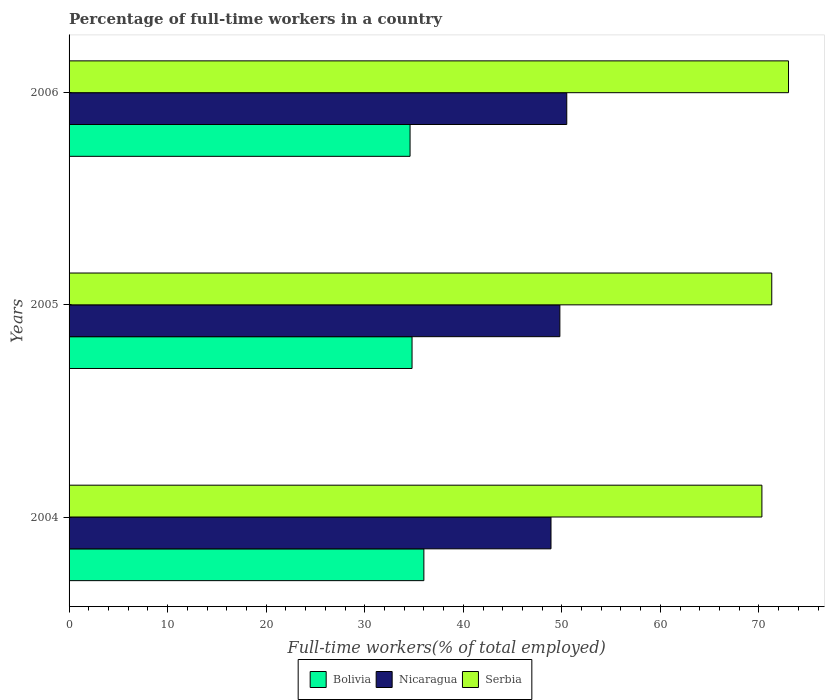How many different coloured bars are there?
Give a very brief answer. 3. Are the number of bars on each tick of the Y-axis equal?
Give a very brief answer. Yes. How many bars are there on the 3rd tick from the bottom?
Your answer should be compact. 3. What is the label of the 3rd group of bars from the top?
Make the answer very short. 2004. In how many cases, is the number of bars for a given year not equal to the number of legend labels?
Your answer should be compact. 0. What is the percentage of full-time workers in Serbia in 2005?
Your answer should be compact. 71.3. Across all years, what is the maximum percentage of full-time workers in Bolivia?
Provide a succinct answer. 36. Across all years, what is the minimum percentage of full-time workers in Nicaragua?
Keep it short and to the point. 48.9. What is the total percentage of full-time workers in Nicaragua in the graph?
Give a very brief answer. 149.2. What is the difference between the percentage of full-time workers in Nicaragua in 2004 and that in 2006?
Provide a succinct answer. -1.6. What is the difference between the percentage of full-time workers in Bolivia in 2004 and the percentage of full-time workers in Serbia in 2006?
Offer a terse response. -37. What is the average percentage of full-time workers in Bolivia per year?
Your response must be concise. 35.13. In the year 2006, what is the difference between the percentage of full-time workers in Serbia and percentage of full-time workers in Bolivia?
Give a very brief answer. 38.4. In how many years, is the percentage of full-time workers in Bolivia greater than 58 %?
Provide a succinct answer. 0. What is the ratio of the percentage of full-time workers in Bolivia in 2004 to that in 2005?
Provide a short and direct response. 1.03. What is the difference between the highest and the second highest percentage of full-time workers in Serbia?
Provide a short and direct response. 1.7. What is the difference between the highest and the lowest percentage of full-time workers in Bolivia?
Your answer should be compact. 1.4. Is the sum of the percentage of full-time workers in Serbia in 2004 and 2006 greater than the maximum percentage of full-time workers in Bolivia across all years?
Your answer should be compact. Yes. What does the 1st bar from the top in 2004 represents?
Provide a short and direct response. Serbia. What does the 2nd bar from the bottom in 2006 represents?
Your response must be concise. Nicaragua. How many bars are there?
Your answer should be compact. 9. Are all the bars in the graph horizontal?
Provide a succinct answer. Yes. What is the title of the graph?
Your answer should be compact. Percentage of full-time workers in a country. What is the label or title of the X-axis?
Your answer should be very brief. Full-time workers(% of total employed). What is the Full-time workers(% of total employed) of Nicaragua in 2004?
Your answer should be compact. 48.9. What is the Full-time workers(% of total employed) in Serbia in 2004?
Make the answer very short. 70.3. What is the Full-time workers(% of total employed) of Bolivia in 2005?
Ensure brevity in your answer.  34.8. What is the Full-time workers(% of total employed) of Nicaragua in 2005?
Your answer should be very brief. 49.8. What is the Full-time workers(% of total employed) in Serbia in 2005?
Provide a short and direct response. 71.3. What is the Full-time workers(% of total employed) in Bolivia in 2006?
Make the answer very short. 34.6. What is the Full-time workers(% of total employed) in Nicaragua in 2006?
Ensure brevity in your answer.  50.5. Across all years, what is the maximum Full-time workers(% of total employed) in Bolivia?
Your answer should be very brief. 36. Across all years, what is the maximum Full-time workers(% of total employed) of Nicaragua?
Provide a succinct answer. 50.5. Across all years, what is the minimum Full-time workers(% of total employed) of Bolivia?
Keep it short and to the point. 34.6. Across all years, what is the minimum Full-time workers(% of total employed) of Nicaragua?
Provide a succinct answer. 48.9. Across all years, what is the minimum Full-time workers(% of total employed) of Serbia?
Make the answer very short. 70.3. What is the total Full-time workers(% of total employed) of Bolivia in the graph?
Provide a succinct answer. 105.4. What is the total Full-time workers(% of total employed) of Nicaragua in the graph?
Your answer should be compact. 149.2. What is the total Full-time workers(% of total employed) of Serbia in the graph?
Make the answer very short. 214.6. What is the difference between the Full-time workers(% of total employed) of Bolivia in 2004 and that in 2005?
Make the answer very short. 1.2. What is the difference between the Full-time workers(% of total employed) of Nicaragua in 2004 and that in 2005?
Make the answer very short. -0.9. What is the difference between the Full-time workers(% of total employed) of Bolivia in 2004 and that in 2006?
Provide a succinct answer. 1.4. What is the difference between the Full-time workers(% of total employed) in Nicaragua in 2005 and that in 2006?
Provide a short and direct response. -0.7. What is the difference between the Full-time workers(% of total employed) in Bolivia in 2004 and the Full-time workers(% of total employed) in Serbia in 2005?
Provide a succinct answer. -35.3. What is the difference between the Full-time workers(% of total employed) of Nicaragua in 2004 and the Full-time workers(% of total employed) of Serbia in 2005?
Provide a succinct answer. -22.4. What is the difference between the Full-time workers(% of total employed) of Bolivia in 2004 and the Full-time workers(% of total employed) of Nicaragua in 2006?
Offer a terse response. -14.5. What is the difference between the Full-time workers(% of total employed) of Bolivia in 2004 and the Full-time workers(% of total employed) of Serbia in 2006?
Your response must be concise. -37. What is the difference between the Full-time workers(% of total employed) of Nicaragua in 2004 and the Full-time workers(% of total employed) of Serbia in 2006?
Your answer should be very brief. -24.1. What is the difference between the Full-time workers(% of total employed) in Bolivia in 2005 and the Full-time workers(% of total employed) in Nicaragua in 2006?
Make the answer very short. -15.7. What is the difference between the Full-time workers(% of total employed) of Bolivia in 2005 and the Full-time workers(% of total employed) of Serbia in 2006?
Your response must be concise. -38.2. What is the difference between the Full-time workers(% of total employed) of Nicaragua in 2005 and the Full-time workers(% of total employed) of Serbia in 2006?
Offer a very short reply. -23.2. What is the average Full-time workers(% of total employed) in Bolivia per year?
Make the answer very short. 35.13. What is the average Full-time workers(% of total employed) of Nicaragua per year?
Your answer should be compact. 49.73. What is the average Full-time workers(% of total employed) in Serbia per year?
Give a very brief answer. 71.53. In the year 2004, what is the difference between the Full-time workers(% of total employed) of Bolivia and Full-time workers(% of total employed) of Nicaragua?
Make the answer very short. -12.9. In the year 2004, what is the difference between the Full-time workers(% of total employed) of Bolivia and Full-time workers(% of total employed) of Serbia?
Your response must be concise. -34.3. In the year 2004, what is the difference between the Full-time workers(% of total employed) in Nicaragua and Full-time workers(% of total employed) in Serbia?
Your answer should be compact. -21.4. In the year 2005, what is the difference between the Full-time workers(% of total employed) of Bolivia and Full-time workers(% of total employed) of Nicaragua?
Keep it short and to the point. -15. In the year 2005, what is the difference between the Full-time workers(% of total employed) of Bolivia and Full-time workers(% of total employed) of Serbia?
Make the answer very short. -36.5. In the year 2005, what is the difference between the Full-time workers(% of total employed) in Nicaragua and Full-time workers(% of total employed) in Serbia?
Keep it short and to the point. -21.5. In the year 2006, what is the difference between the Full-time workers(% of total employed) in Bolivia and Full-time workers(% of total employed) in Nicaragua?
Your answer should be very brief. -15.9. In the year 2006, what is the difference between the Full-time workers(% of total employed) of Bolivia and Full-time workers(% of total employed) of Serbia?
Your answer should be compact. -38.4. In the year 2006, what is the difference between the Full-time workers(% of total employed) of Nicaragua and Full-time workers(% of total employed) of Serbia?
Your response must be concise. -22.5. What is the ratio of the Full-time workers(% of total employed) of Bolivia in 2004 to that in 2005?
Make the answer very short. 1.03. What is the ratio of the Full-time workers(% of total employed) of Nicaragua in 2004 to that in 2005?
Your answer should be compact. 0.98. What is the ratio of the Full-time workers(% of total employed) of Serbia in 2004 to that in 2005?
Your answer should be compact. 0.99. What is the ratio of the Full-time workers(% of total employed) of Bolivia in 2004 to that in 2006?
Ensure brevity in your answer.  1.04. What is the ratio of the Full-time workers(% of total employed) in Nicaragua in 2004 to that in 2006?
Your answer should be compact. 0.97. What is the ratio of the Full-time workers(% of total employed) in Serbia in 2004 to that in 2006?
Offer a terse response. 0.96. What is the ratio of the Full-time workers(% of total employed) in Bolivia in 2005 to that in 2006?
Your answer should be very brief. 1.01. What is the ratio of the Full-time workers(% of total employed) in Nicaragua in 2005 to that in 2006?
Offer a terse response. 0.99. What is the ratio of the Full-time workers(% of total employed) of Serbia in 2005 to that in 2006?
Provide a short and direct response. 0.98. What is the difference between the highest and the second highest Full-time workers(% of total employed) of Nicaragua?
Provide a succinct answer. 0.7. What is the difference between the highest and the lowest Full-time workers(% of total employed) of Bolivia?
Your answer should be very brief. 1.4. What is the difference between the highest and the lowest Full-time workers(% of total employed) in Nicaragua?
Your answer should be very brief. 1.6. What is the difference between the highest and the lowest Full-time workers(% of total employed) of Serbia?
Offer a very short reply. 2.7. 